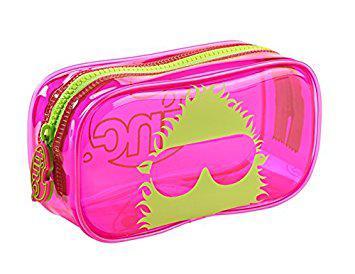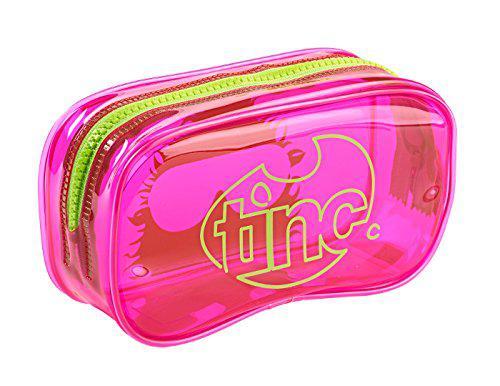The first image is the image on the left, the second image is the image on the right. Assess this claim about the two images: "The pencil case to the left contains a lot of the color pink.". Correct or not? Answer yes or no. Yes. The first image is the image on the left, the second image is the image on the right. For the images displayed, is the sentence "No case is displayed open, and at least one rectangular case with rounded corners and hot pink color scheme is displayed standing on its long side." factually correct? Answer yes or no. Yes. 